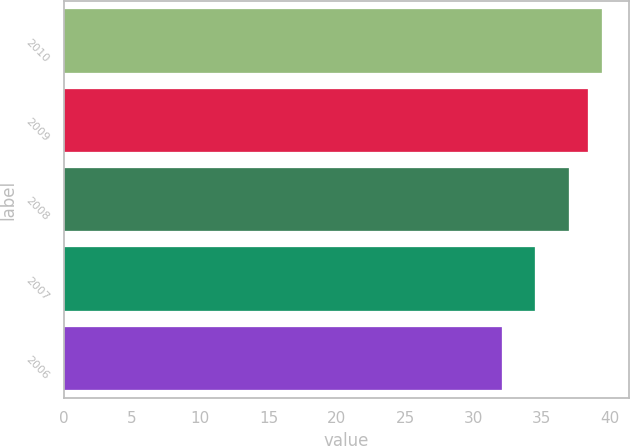<chart> <loc_0><loc_0><loc_500><loc_500><bar_chart><fcel>2010<fcel>2009<fcel>2008<fcel>2007<fcel>2006<nl><fcel>39.42<fcel>38.37<fcel>37.03<fcel>34.47<fcel>32.08<nl></chart> 